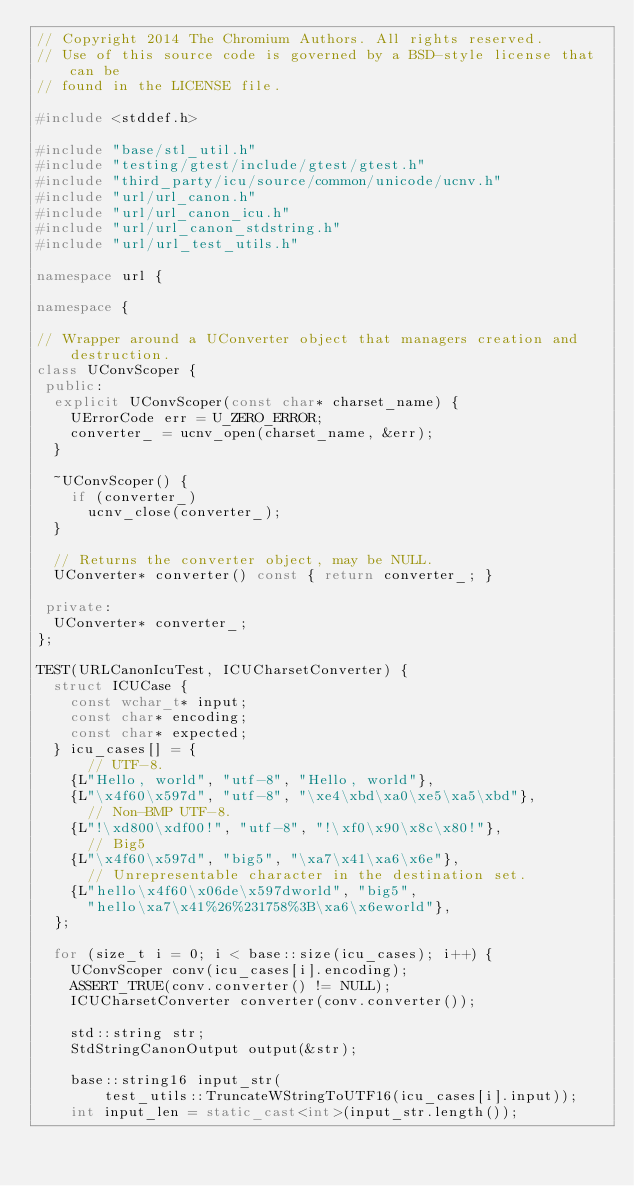Convert code to text. <code><loc_0><loc_0><loc_500><loc_500><_C++_>// Copyright 2014 The Chromium Authors. All rights reserved.
// Use of this source code is governed by a BSD-style license that can be
// found in the LICENSE file.

#include <stddef.h>

#include "base/stl_util.h"
#include "testing/gtest/include/gtest/gtest.h"
#include "third_party/icu/source/common/unicode/ucnv.h"
#include "url/url_canon.h"
#include "url/url_canon_icu.h"
#include "url/url_canon_stdstring.h"
#include "url/url_test_utils.h"

namespace url {

namespace {

// Wrapper around a UConverter object that managers creation and destruction.
class UConvScoper {
 public:
  explicit UConvScoper(const char* charset_name) {
    UErrorCode err = U_ZERO_ERROR;
    converter_ = ucnv_open(charset_name, &err);
  }

  ~UConvScoper() {
    if (converter_)
      ucnv_close(converter_);
  }

  // Returns the converter object, may be NULL.
  UConverter* converter() const { return converter_; }

 private:
  UConverter* converter_;
};

TEST(URLCanonIcuTest, ICUCharsetConverter) {
  struct ICUCase {
    const wchar_t* input;
    const char* encoding;
    const char* expected;
  } icu_cases[] = {
      // UTF-8.
    {L"Hello, world", "utf-8", "Hello, world"},
    {L"\x4f60\x597d", "utf-8", "\xe4\xbd\xa0\xe5\xa5\xbd"},
      // Non-BMP UTF-8.
    {L"!\xd800\xdf00!", "utf-8", "!\xf0\x90\x8c\x80!"},
      // Big5
    {L"\x4f60\x597d", "big5", "\xa7\x41\xa6\x6e"},
      // Unrepresentable character in the destination set.
    {L"hello\x4f60\x06de\x597dworld", "big5",
      "hello\xa7\x41%26%231758%3B\xa6\x6eworld"},
  };

  for (size_t i = 0; i < base::size(icu_cases); i++) {
    UConvScoper conv(icu_cases[i].encoding);
    ASSERT_TRUE(conv.converter() != NULL);
    ICUCharsetConverter converter(conv.converter());

    std::string str;
    StdStringCanonOutput output(&str);

    base::string16 input_str(
        test_utils::TruncateWStringToUTF16(icu_cases[i].input));
    int input_len = static_cast<int>(input_str.length());</code> 